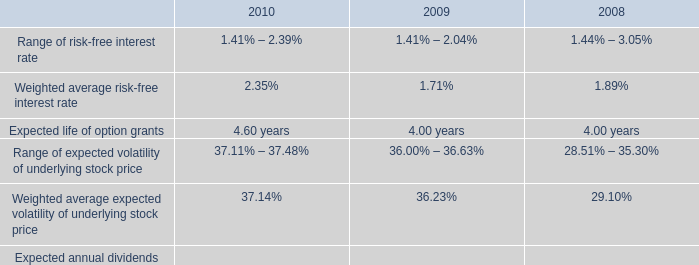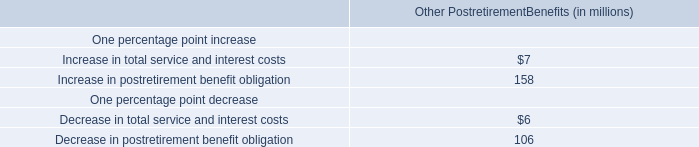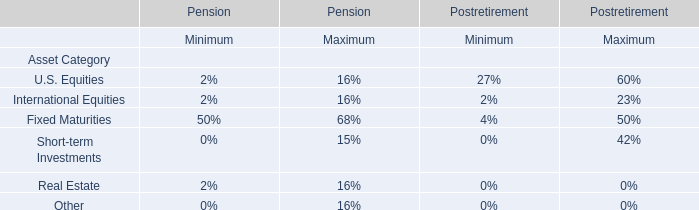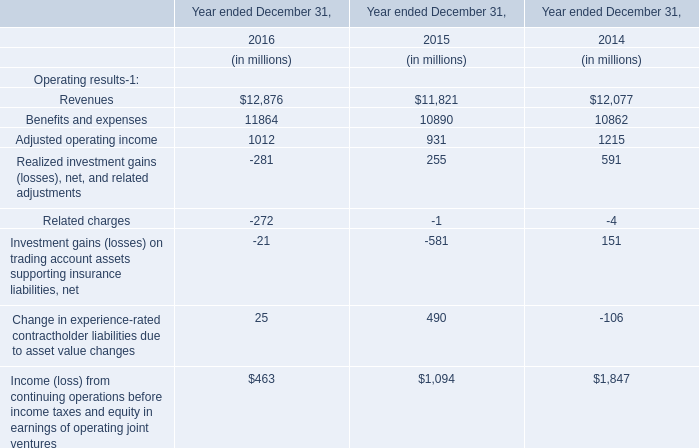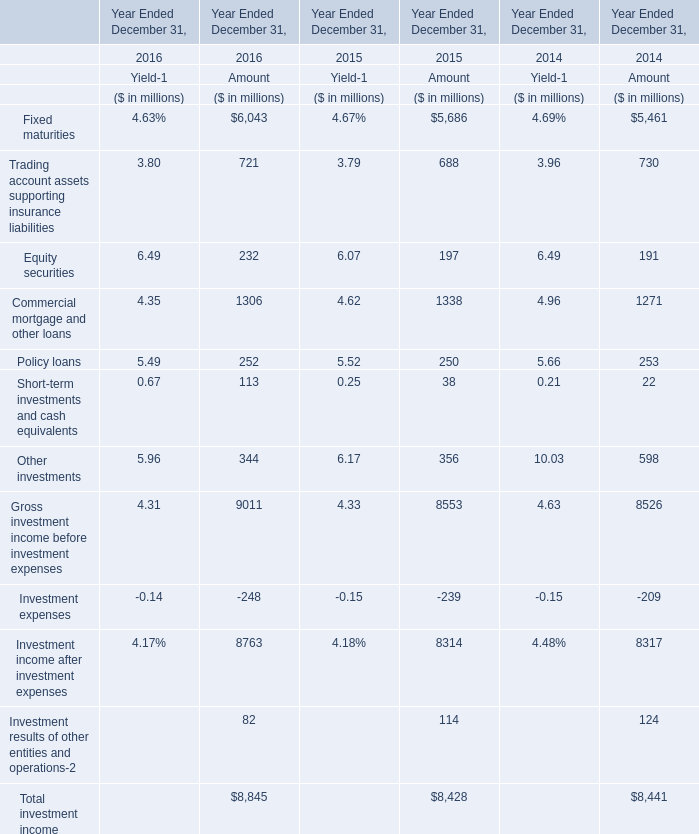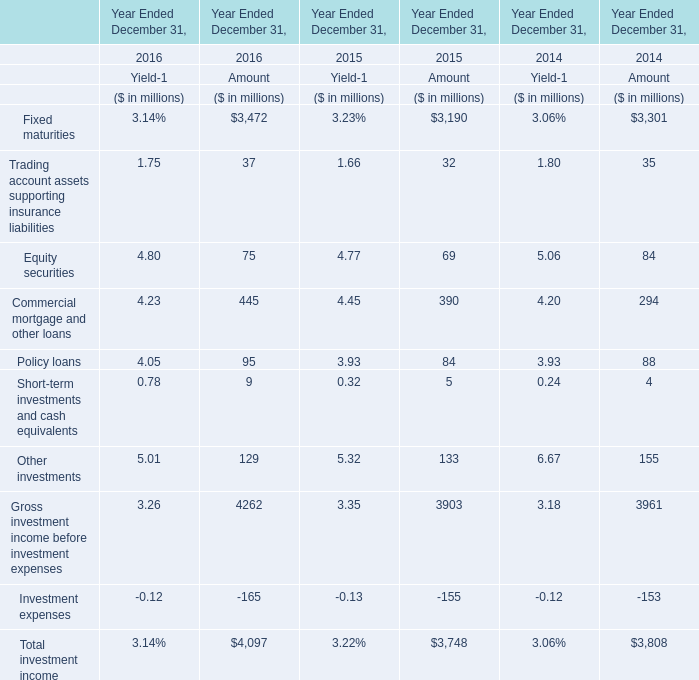In which section the sum of rading account assets supporting insurance liabilities has the highest value? 
Answer: 2016. 